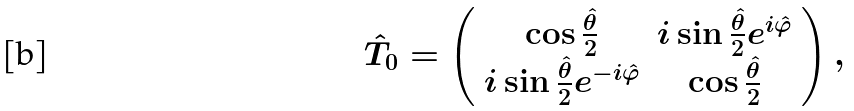<formula> <loc_0><loc_0><loc_500><loc_500>\hat { T } _ { 0 } = \left ( \begin{array} { c c } \cos \frac { \hat { \theta } } { 2 } & i \sin \frac { \hat { \theta } } { 2 } e ^ { i \hat { \varphi } } \\ i \sin \frac { \hat { \theta } } { 2 } e ^ { - i \hat { \varphi } } & \cos \frac { \hat { \theta } } { 2 } \end{array} \right ) ,</formula> 